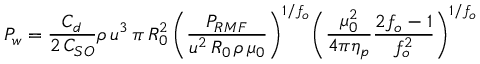<formula> <loc_0><loc_0><loc_500><loc_500>P _ { w } = { \frac { C _ { d } } { 2 \, C _ { S O } } } \rho \, u ^ { 3 } \, \pi \, R _ { 0 } ^ { 2 } \, { \left ( } { \frac { P _ { R M F } } { u ^ { 2 } \, R _ { 0 } \, \rho \, \mu _ { 0 } } } { \right ) } ^ { 1 / f _ { o } } { \left ( } { \frac { \mu _ { 0 } ^ { 2 } } { 4 \pi \eta _ { p } } } { \frac { 2 f _ { o } - 1 } { f _ { o } ^ { 2 } } } { \right ) } ^ { 1 / f _ { o } }</formula> 